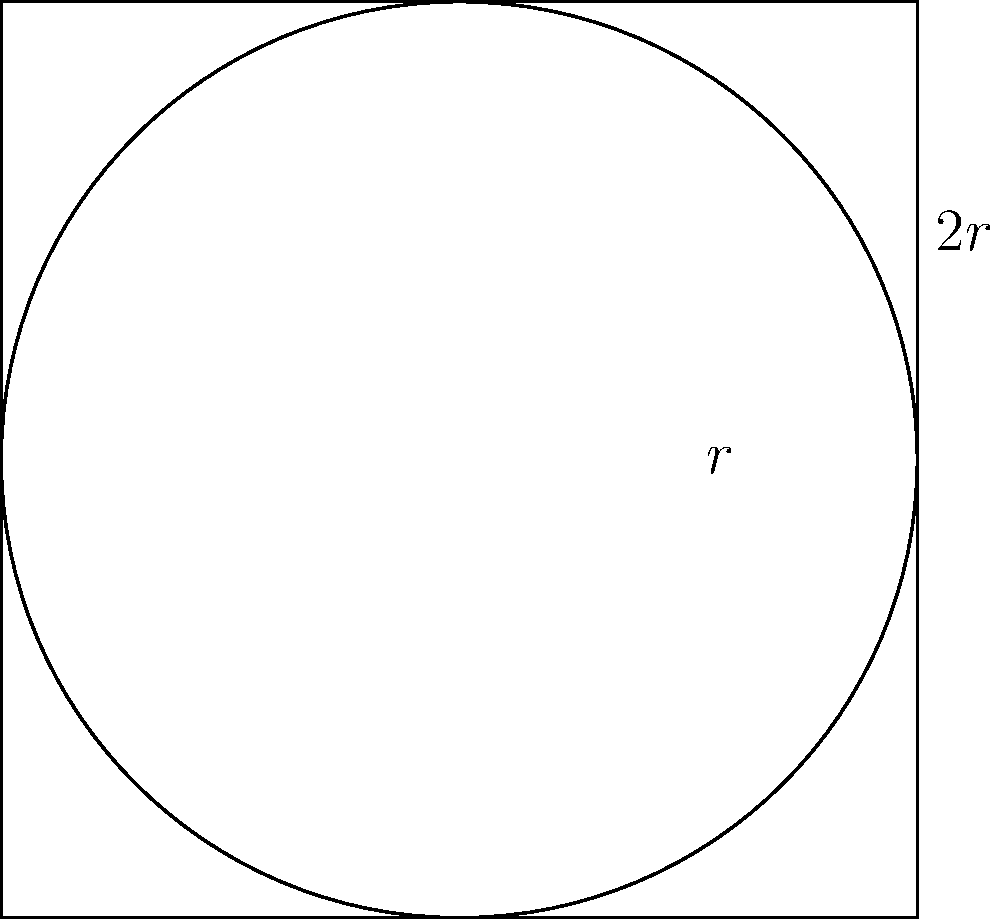A square has a side length of $2r$, and a circle is inscribed within it, touching all four sides. Calculate the difference in area between the square and the inscribed circle in terms of $r$. Let's approach this step-by-step:

1) First, we need to calculate the area of the square:
   Area of square = side length squared
   $A_s = (2r)^2 = 4r^2$

2) Next, we calculate the area of the circle:
   Area of circle = $\pi r^2$

3) Now, we can find the difference in area:
   Difference = Area of square - Area of circle
   $D = A_s - A_c = 4r^2 - \pi r^2$

4) Simplifying:
   $D = r^2(4 - \pi)$

5) This can be further simplified to:
   $D = (4 - \pi)r^2$

Therefore, the difference in area between the square and the inscribed circle is $(4 - \pi)r^2$.
Answer: $(4 - \pi)r^2$ 